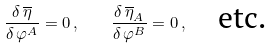<formula> <loc_0><loc_0><loc_500><loc_500>\frac { \delta \, \overline { \eta } } { \delta \, \varphi ^ { A } } = 0 \, , \quad \frac { \delta \, \overline { \eta } _ { A } } { \delta \, \varphi ^ { B } } = 0 \, , \quad \text {etc.}</formula> 